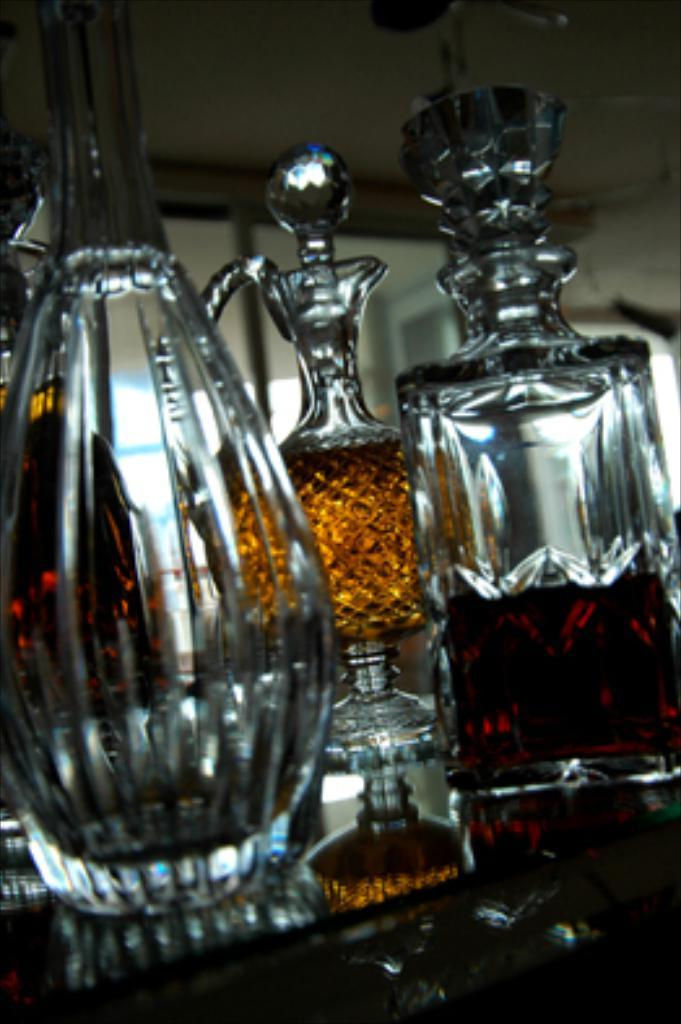What type of containers are visible in the image? There are glass bottles in the image. What is inside some of the bottles? Some of the bottles are filled with liquid. What type of attraction can be seen in the background of the image? There is no attraction visible in the image; it only features glass bottles filled with liquid. 